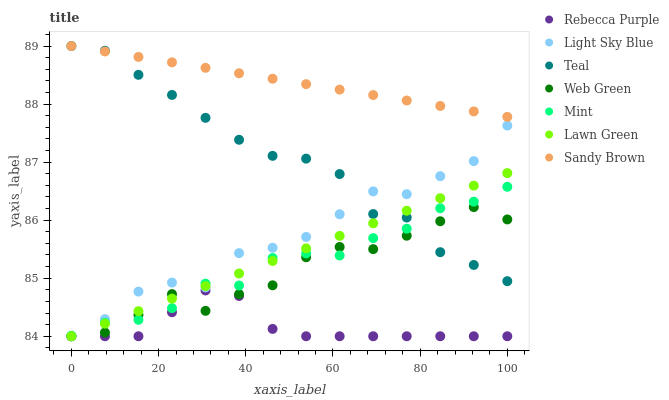Does Rebecca Purple have the minimum area under the curve?
Answer yes or no. Yes. Does Sandy Brown have the maximum area under the curve?
Answer yes or no. Yes. Does Web Green have the minimum area under the curve?
Answer yes or no. No. Does Web Green have the maximum area under the curve?
Answer yes or no. No. Is Lawn Green the smoothest?
Answer yes or no. Yes. Is Light Sky Blue the roughest?
Answer yes or no. Yes. Is Sandy Brown the smoothest?
Answer yes or no. No. Is Sandy Brown the roughest?
Answer yes or no. No. Does Lawn Green have the lowest value?
Answer yes or no. Yes. Does Sandy Brown have the lowest value?
Answer yes or no. No. Does Teal have the highest value?
Answer yes or no. Yes. Does Web Green have the highest value?
Answer yes or no. No. Is Web Green less than Sandy Brown?
Answer yes or no. Yes. Is Sandy Brown greater than Lawn Green?
Answer yes or no. Yes. Does Web Green intersect Mint?
Answer yes or no. Yes. Is Web Green less than Mint?
Answer yes or no. No. Is Web Green greater than Mint?
Answer yes or no. No. Does Web Green intersect Sandy Brown?
Answer yes or no. No. 